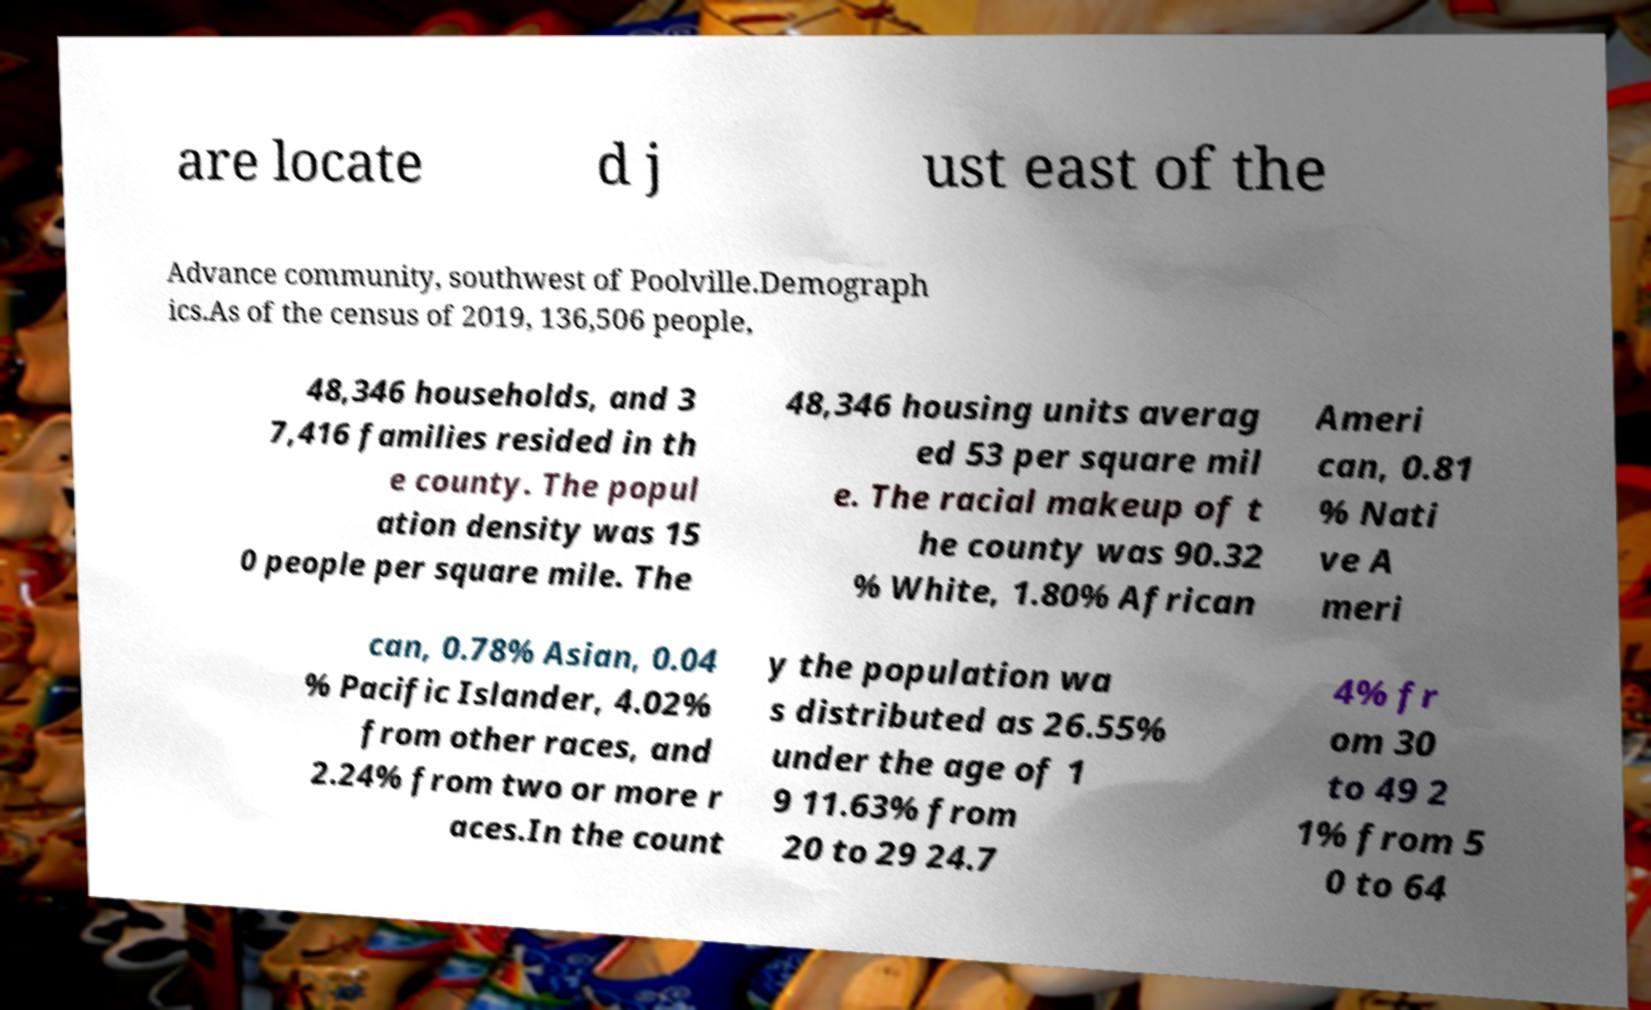Could you assist in decoding the text presented in this image and type it out clearly? are locate d j ust east of the Advance community, southwest of Poolville.Demograph ics.As of the census of 2019, 136,506 people, 48,346 households, and 3 7,416 families resided in th e county. The popul ation density was 15 0 people per square mile. The 48,346 housing units averag ed 53 per square mil e. The racial makeup of t he county was 90.32 % White, 1.80% African Ameri can, 0.81 % Nati ve A meri can, 0.78% Asian, 0.04 % Pacific Islander, 4.02% from other races, and 2.24% from two or more r aces.In the count y the population wa s distributed as 26.55% under the age of 1 9 11.63% from 20 to 29 24.7 4% fr om 30 to 49 2 1% from 5 0 to 64 